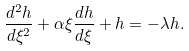Convert formula to latex. <formula><loc_0><loc_0><loc_500><loc_500>\frac { d ^ { 2 } h } { d \xi ^ { 2 } } + \alpha \xi \frac { d h } { d \xi } + h = - \lambda h .</formula> 